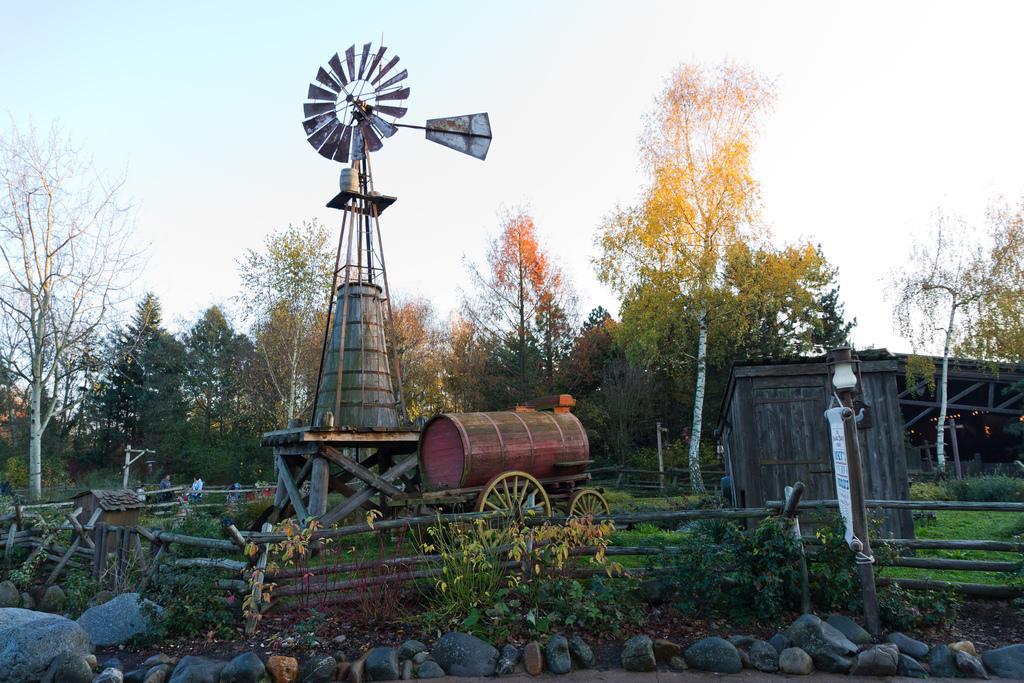How would you summarize this image in a sentence or two? In this image we can see a windmill, wooden objects and other objects. In the background of the image there are some trees, shed and other objects. At the top of the image there is the sky. At the bottom of the image there are rocks. 